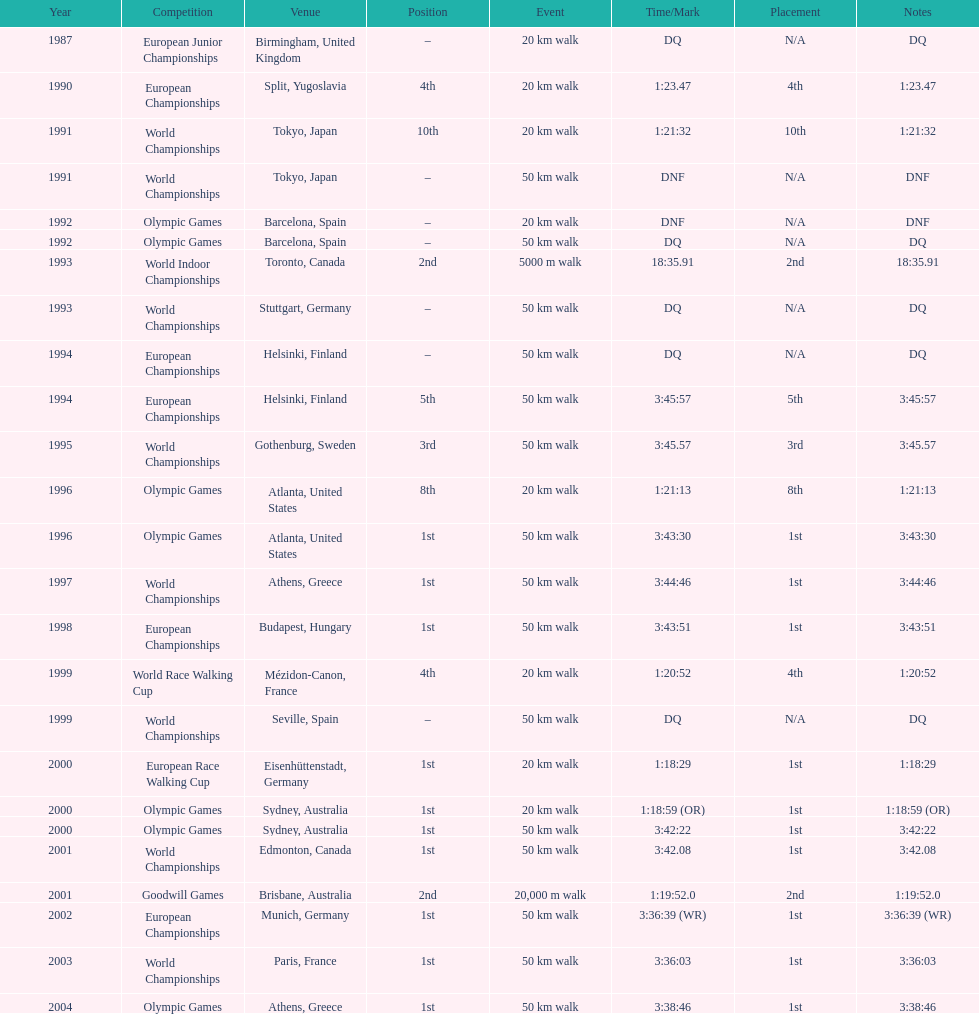In the 2004 olympics, how much time was required to complete the 50 km walk? 3:38:46. 